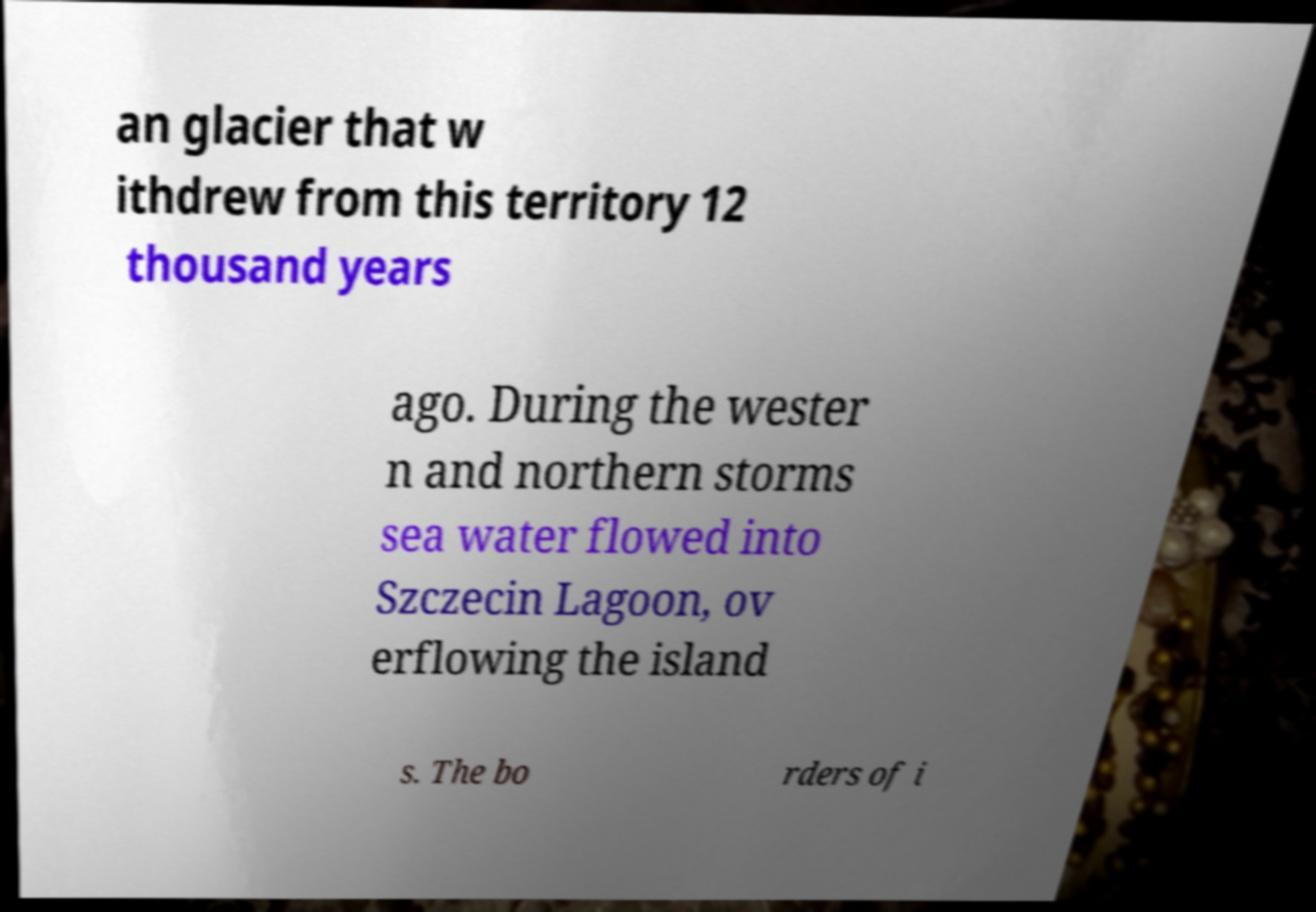Please identify and transcribe the text found in this image. an glacier that w ithdrew from this territory 12 thousand years ago. During the wester n and northern storms sea water flowed into Szczecin Lagoon, ov erflowing the island s. The bo rders of i 